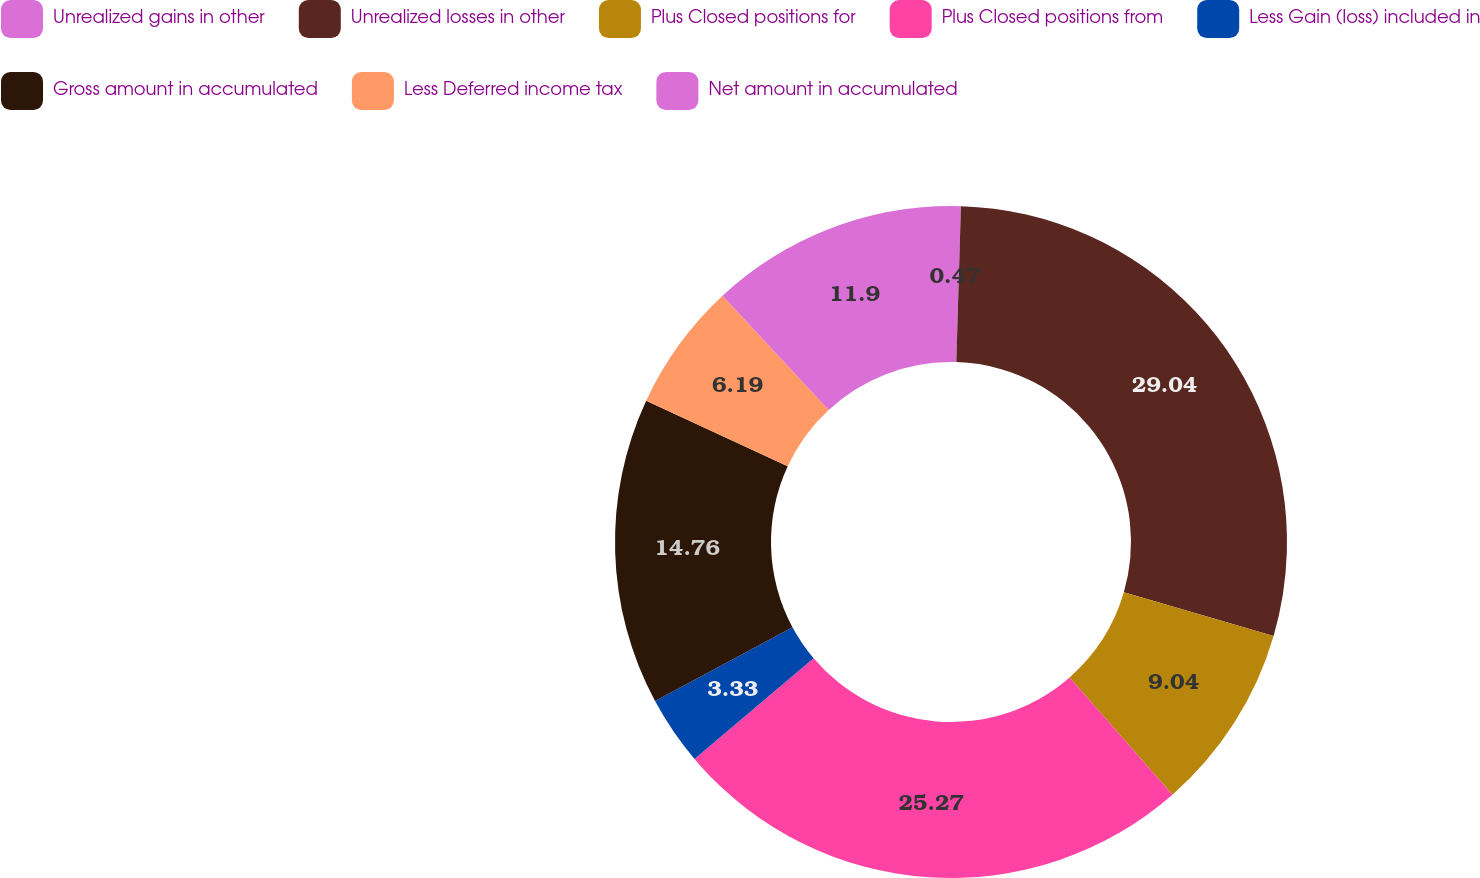Convert chart. <chart><loc_0><loc_0><loc_500><loc_500><pie_chart><fcel>Unrealized gains in other<fcel>Unrealized losses in other<fcel>Plus Closed positions for<fcel>Plus Closed positions from<fcel>Less Gain (loss) included in<fcel>Gross amount in accumulated<fcel>Less Deferred income tax<fcel>Net amount in accumulated<nl><fcel>0.47%<fcel>29.04%<fcel>9.04%<fcel>25.27%<fcel>3.33%<fcel>14.76%<fcel>6.19%<fcel>11.9%<nl></chart> 